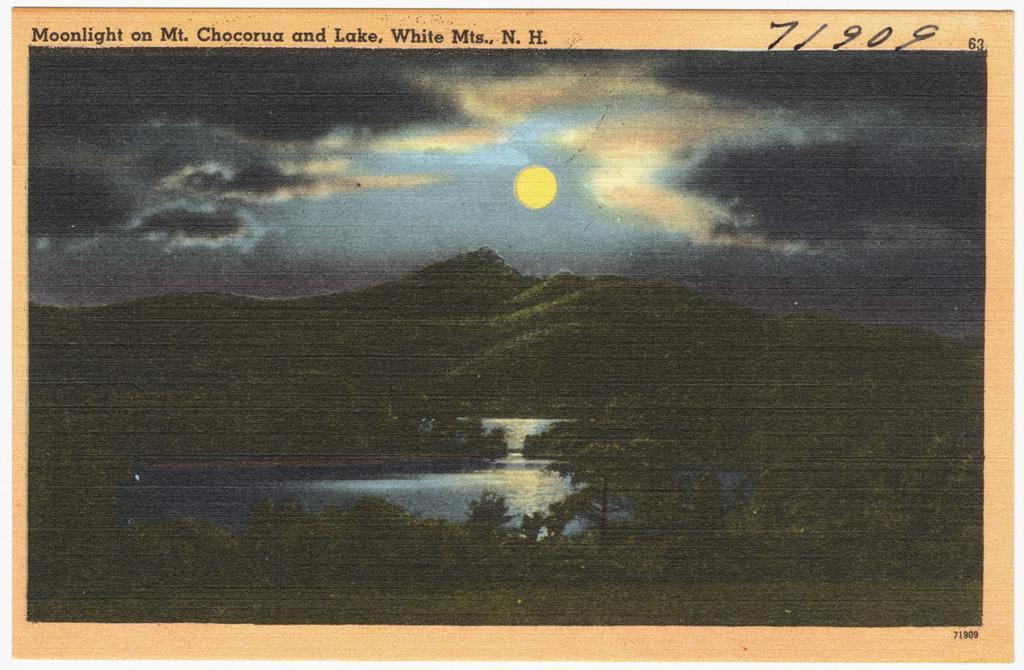How would you summarize this image in a sentence or two? In this image there are trees, water and the sky is cloudy and there is a sun in the sky. 